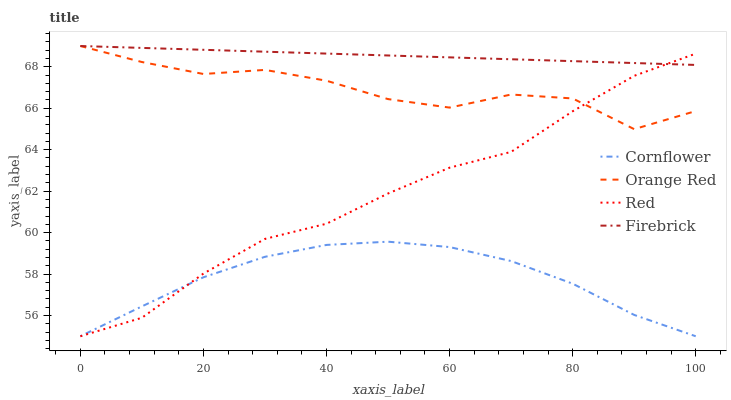Does Cornflower have the minimum area under the curve?
Answer yes or no. Yes. Does Firebrick have the maximum area under the curve?
Answer yes or no. Yes. Does Orange Red have the minimum area under the curve?
Answer yes or no. No. Does Orange Red have the maximum area under the curve?
Answer yes or no. No. Is Firebrick the smoothest?
Answer yes or no. Yes. Is Orange Red the roughest?
Answer yes or no. Yes. Is Orange Red the smoothest?
Answer yes or no. No. Is Firebrick the roughest?
Answer yes or no. No. Does Orange Red have the lowest value?
Answer yes or no. No. Does Orange Red have the highest value?
Answer yes or no. Yes. Does Red have the highest value?
Answer yes or no. No. Is Cornflower less than Orange Red?
Answer yes or no. Yes. Is Orange Red greater than Cornflower?
Answer yes or no. Yes. Does Firebrick intersect Red?
Answer yes or no. Yes. Is Firebrick less than Red?
Answer yes or no. No. Is Firebrick greater than Red?
Answer yes or no. No. Does Cornflower intersect Orange Red?
Answer yes or no. No. 